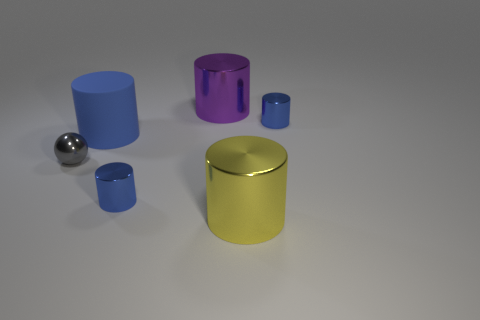Subtract all yellow blocks. How many blue cylinders are left? 3 Subtract 3 cylinders. How many cylinders are left? 2 Subtract all yellow cylinders. How many cylinders are left? 4 Subtract all big blue matte cylinders. How many cylinders are left? 4 Subtract all yellow cylinders. Subtract all purple balls. How many cylinders are left? 4 Add 3 objects. How many objects exist? 9 Subtract all cylinders. How many objects are left? 1 Subtract 0 cyan balls. How many objects are left? 6 Subtract all large green objects. Subtract all big blue matte cylinders. How many objects are left? 5 Add 1 small gray shiny objects. How many small gray shiny objects are left? 2 